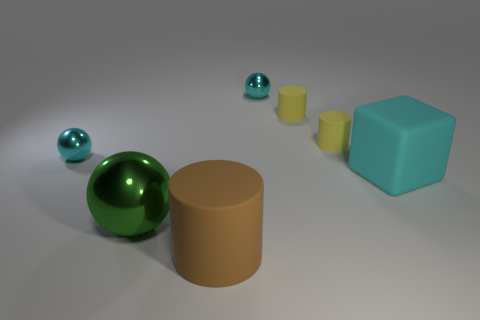Subtract 1 cylinders. How many cylinders are left? 2 Add 1 brown things. How many objects exist? 8 Subtract all blocks. How many objects are left? 6 Subtract all large purple matte things. Subtract all small yellow matte cylinders. How many objects are left? 5 Add 4 big cyan rubber things. How many big cyan rubber things are left? 5 Add 4 large red spheres. How many large red spheres exist? 4 Subtract 0 gray cubes. How many objects are left? 7 